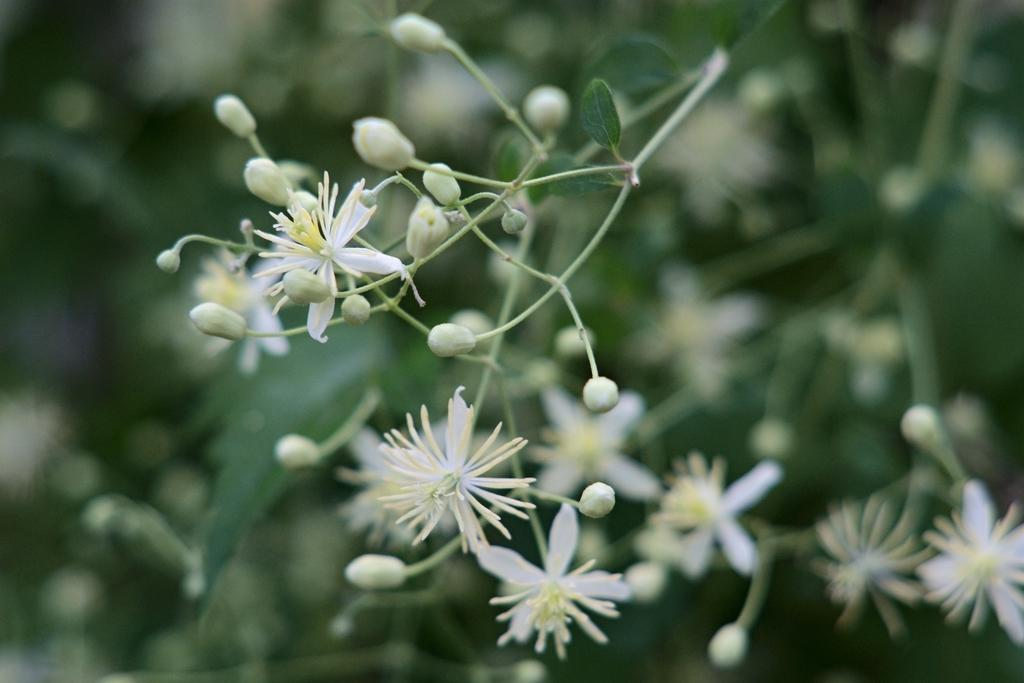What type of flowers can be seen in the image? There are white color flowers in the image. Can you describe the stage of growth for some of the flowers? Yes, there are buds in the image. How many spiders are crawling on the window in the image? There is no window or spiders present in the image. 